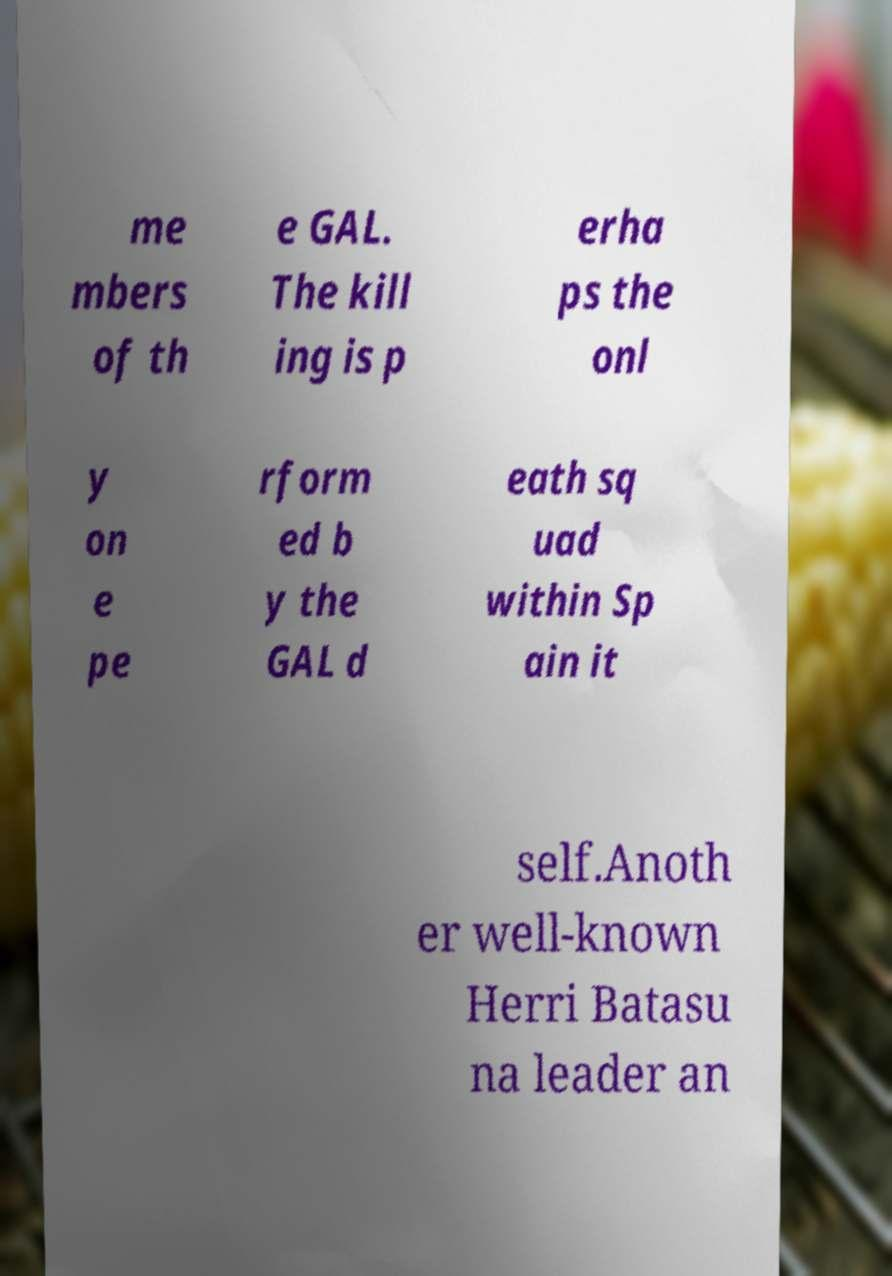Please identify and transcribe the text found in this image. me mbers of th e GAL. The kill ing is p erha ps the onl y on e pe rform ed b y the GAL d eath sq uad within Sp ain it self.Anoth er well-known Herri Batasu na leader an 